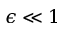Convert formula to latex. <formula><loc_0><loc_0><loc_500><loc_500>\epsilon \ll 1</formula> 